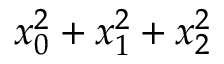<formula> <loc_0><loc_0><loc_500><loc_500>x _ { 0 } ^ { 2 } + x _ { 1 } ^ { 2 } + x _ { 2 } ^ { 2 }</formula> 